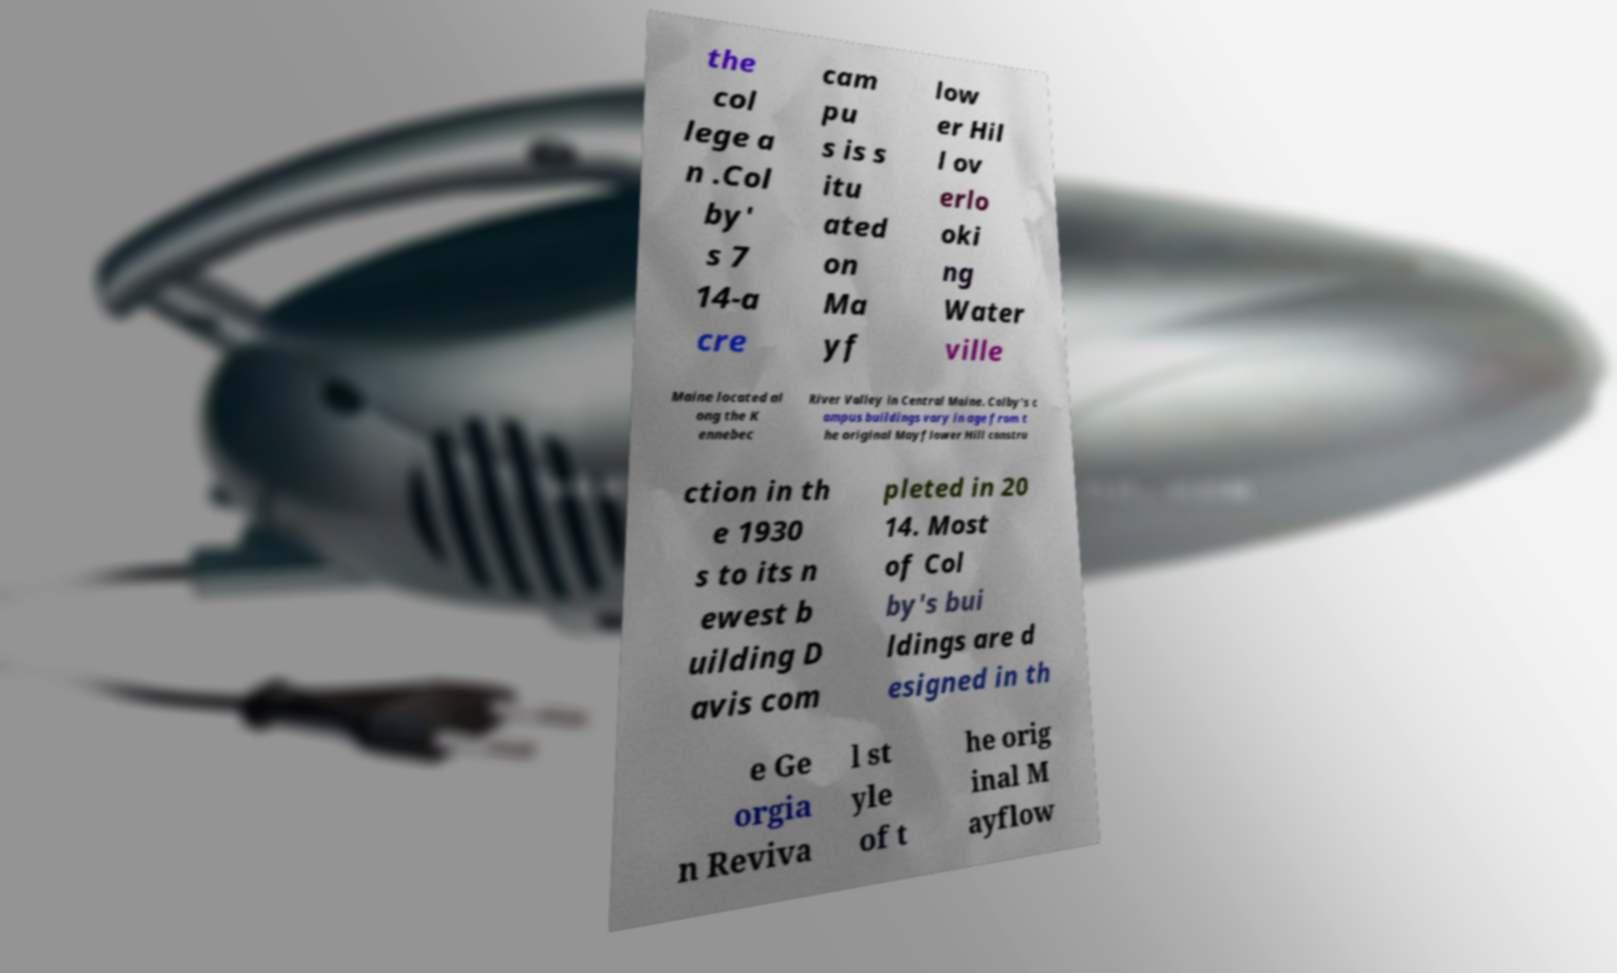I need the written content from this picture converted into text. Can you do that? the col lege a n .Col by' s 7 14-a cre cam pu s is s itu ated on Ma yf low er Hil l ov erlo oki ng Water ville Maine located al ong the K ennebec River Valley in Central Maine. Colby's c ampus buildings vary in age from t he original Mayflower Hill constru ction in th e 1930 s to its n ewest b uilding D avis com pleted in 20 14. Most of Col by's bui ldings are d esigned in th e Ge orgia n Reviva l st yle of t he orig inal M ayflow 